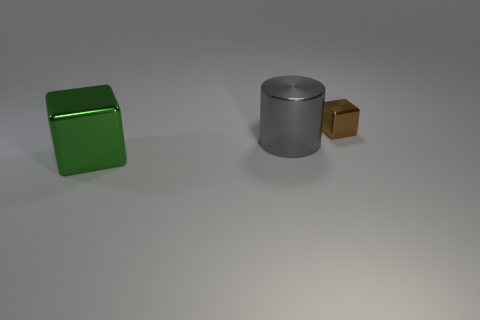How many tiny things are gray shiny things or green objects?
Make the answer very short. 0. There is a shiny object that is to the left of the small brown shiny cube and behind the big green metallic thing; what is its shape?
Provide a short and direct response. Cylinder. Are the large gray thing and the small block made of the same material?
Provide a succinct answer. Yes. There is another metal thing that is the same size as the gray object; what color is it?
Offer a very short reply. Green. What is the color of the thing that is both behind the large shiny block and to the left of the tiny brown thing?
Offer a terse response. Gray. There is a cube in front of the large thing that is to the right of the object on the left side of the big cylinder; how big is it?
Keep it short and to the point. Large. What material is the large gray cylinder?
Your answer should be compact. Metal. Does the green cube have the same material as the big thing that is behind the big green shiny cube?
Your response must be concise. Yes. Is there any other thing that is the same color as the big metal block?
Your answer should be compact. No. Is there a big metal cylinder in front of the metal block that is on the left side of the big metallic object behind the green cube?
Make the answer very short. No. 